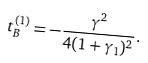Convert formula to latex. <formula><loc_0><loc_0><loc_500><loc_500>t _ { B } ^ { ( 1 ) } = - \frac { \gamma ^ { 2 } } { 4 ( 1 + \gamma _ { 1 } ) ^ { 2 } } .</formula> 